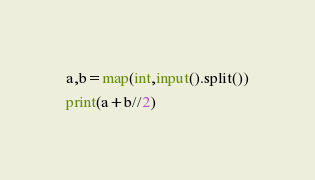<code> <loc_0><loc_0><loc_500><loc_500><_Python_>a,b=map(int,input().split())
print(a+b//2)</code> 